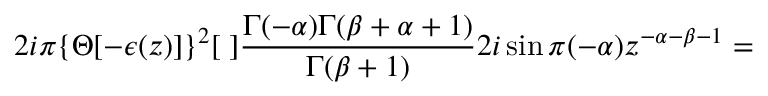<formula> <loc_0><loc_0><loc_500><loc_500>2 i \pi \{ \Theta [ - \epsilon ( z ) ] \} ^ { 2 } [ \, ] \frac { \Gamma ( - \alpha ) \Gamma ( \beta + \alpha + 1 ) } { \Gamma ( \beta + 1 ) } 2 i \sin \pi ( - \alpha ) z ^ { - \alpha - \beta - 1 } =</formula> 